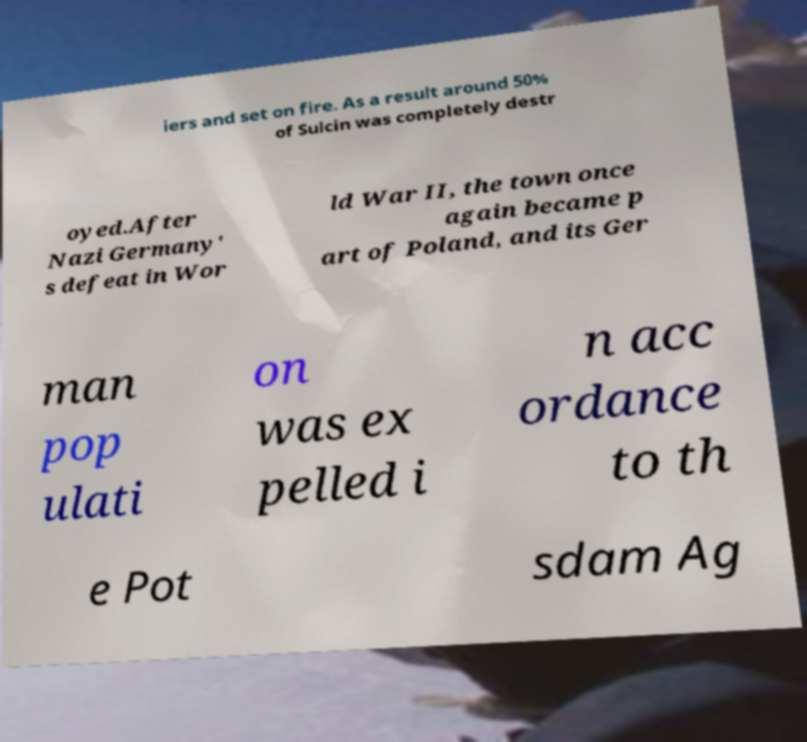Can you read and provide the text displayed in the image?This photo seems to have some interesting text. Can you extract and type it out for me? iers and set on fire. As a result around 50% of Sulcin was completely destr oyed.After Nazi Germany' s defeat in Wor ld War II, the town once again became p art of Poland, and its Ger man pop ulati on was ex pelled i n acc ordance to th e Pot sdam Ag 